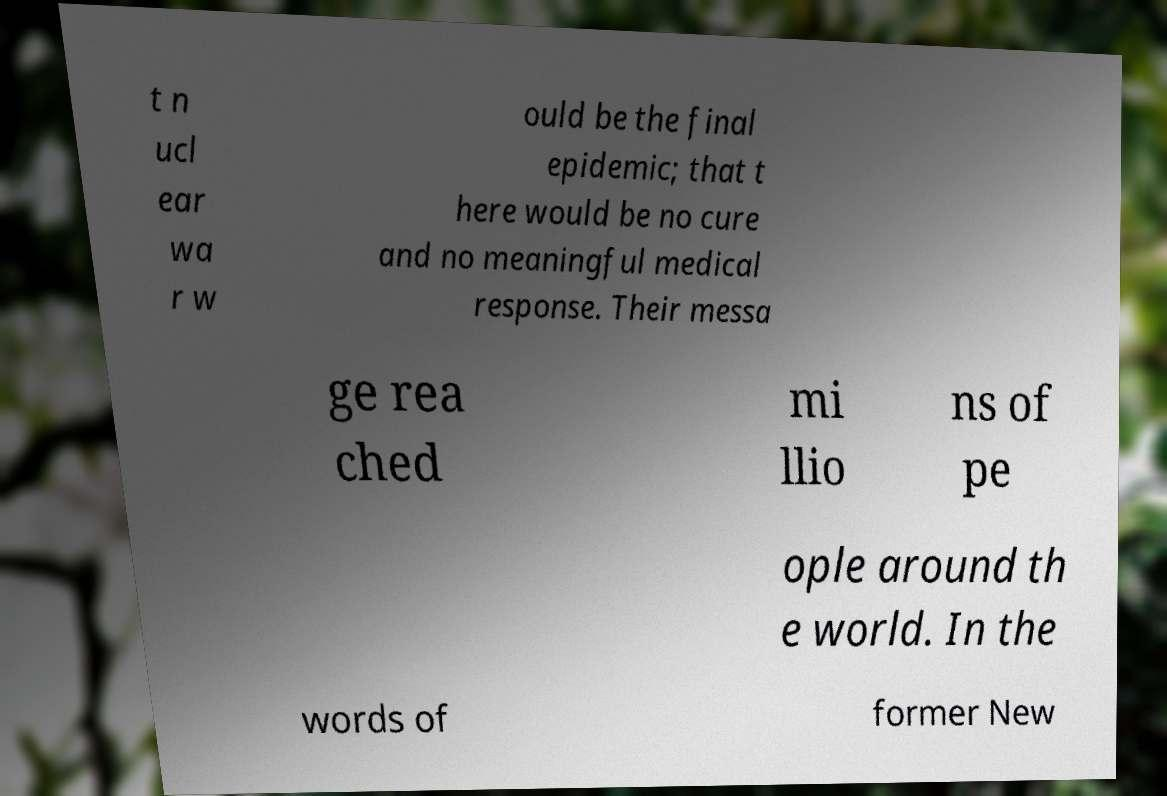For documentation purposes, I need the text within this image transcribed. Could you provide that? t n ucl ear wa r w ould be the final epidemic; that t here would be no cure and no meaningful medical response. Their messa ge rea ched mi llio ns of pe ople around th e world. In the words of former New 